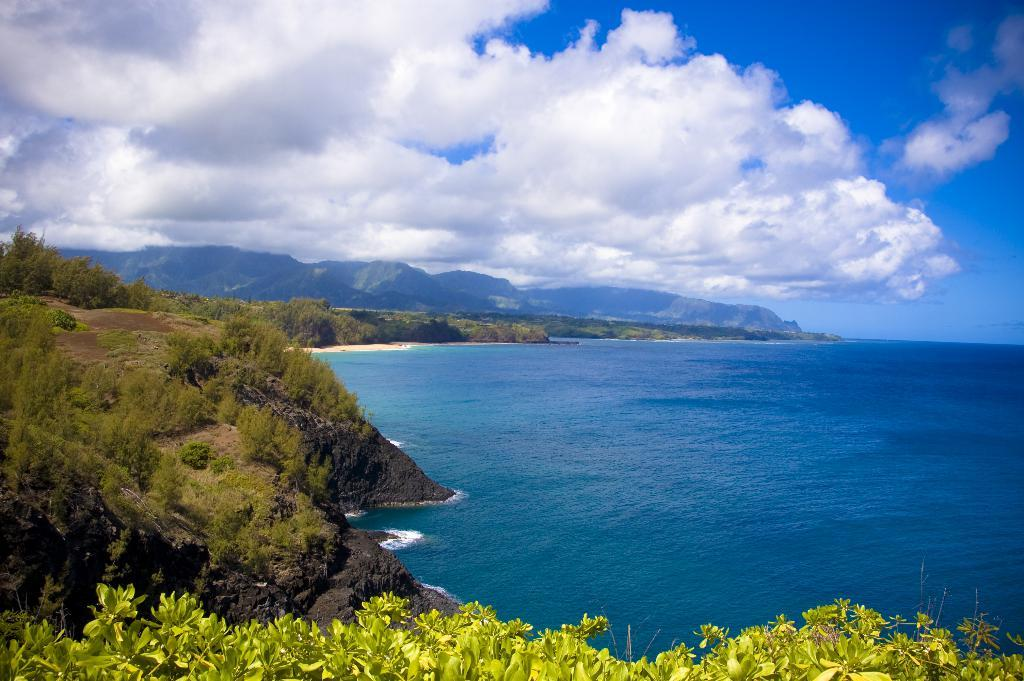What type of vegetation can be seen in the image? There are trees, plants, and grass visible in the image. What type of terrain is present in the image? There are hills and sand visible in the image. What natural element is present in the image? There is water visible in the image. What part of the natural environment is visible in the image? The sky is visible in the image, and there are clouds present. What direction is the teacher pointing in the image? There is no teacher present in the image, so it is not possible to answer that question. 